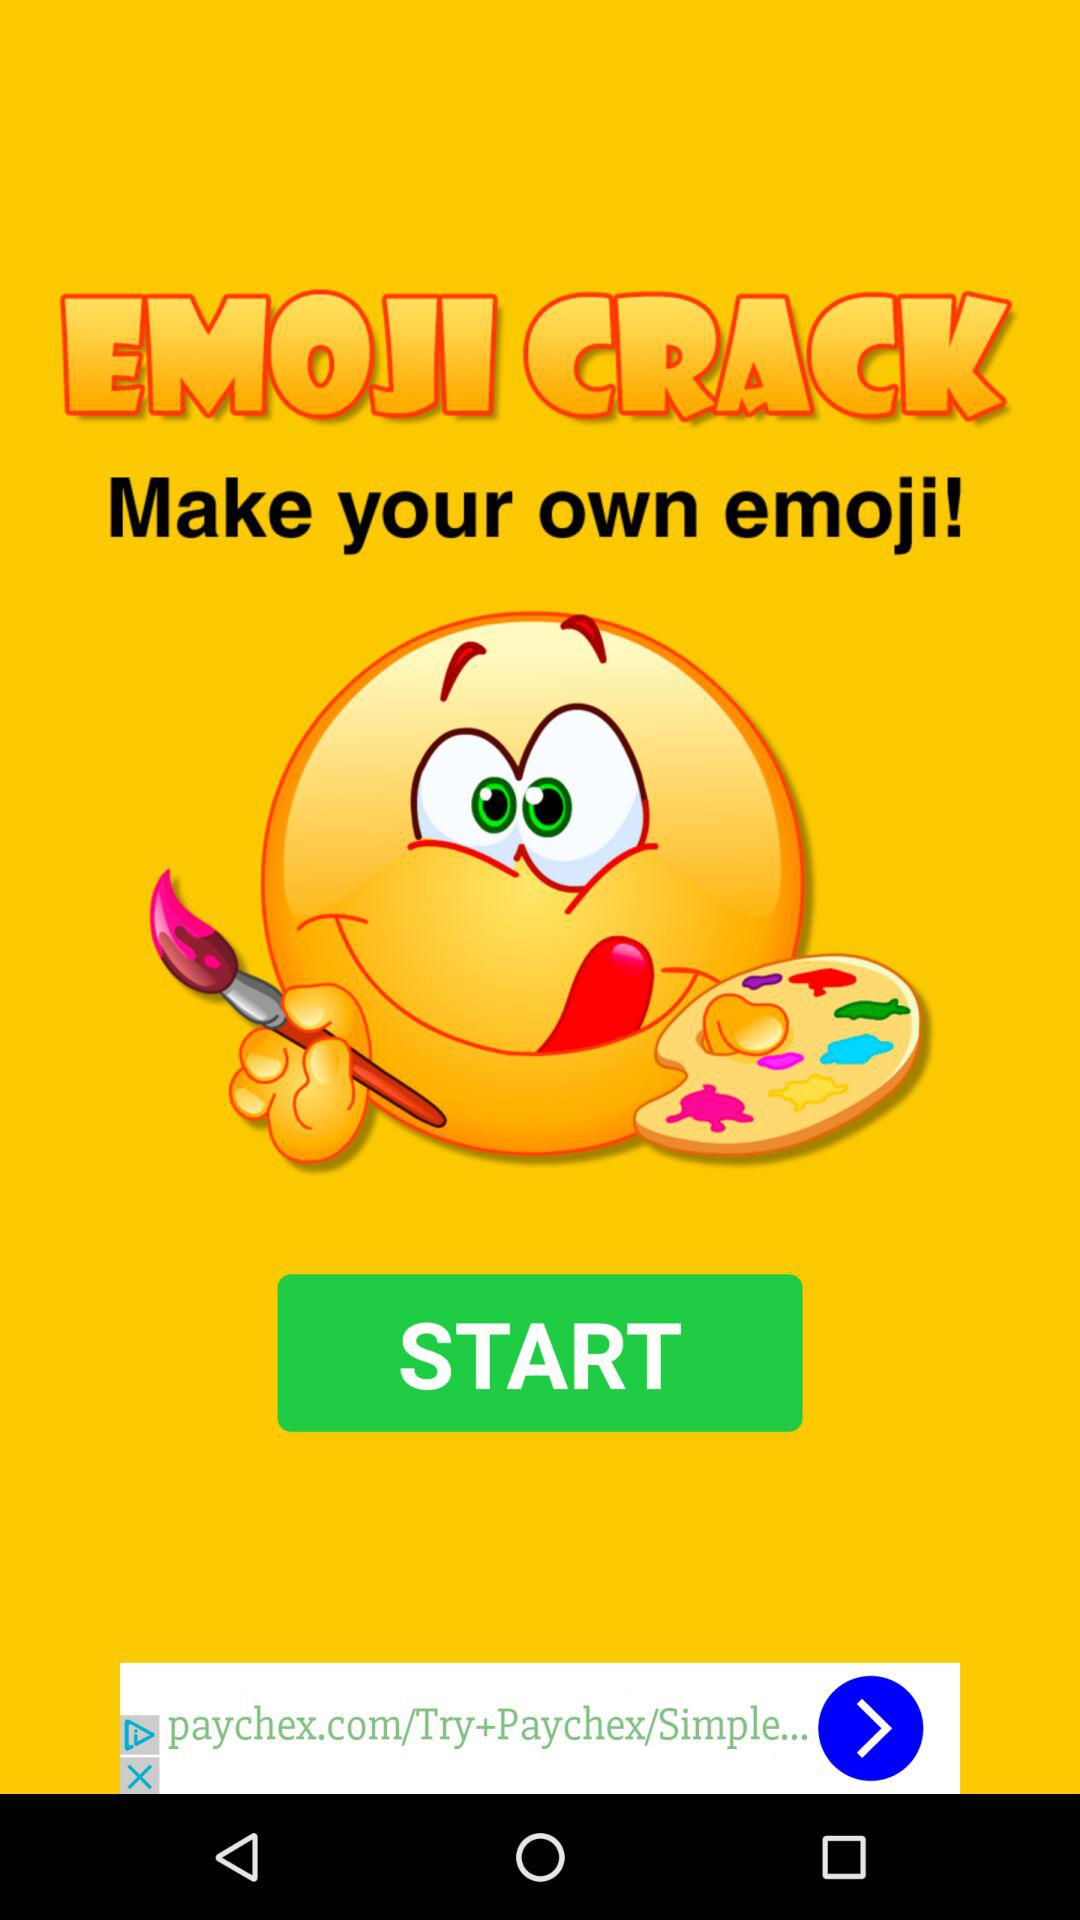What is the application name? The application name is "EMOJI CRACK". 